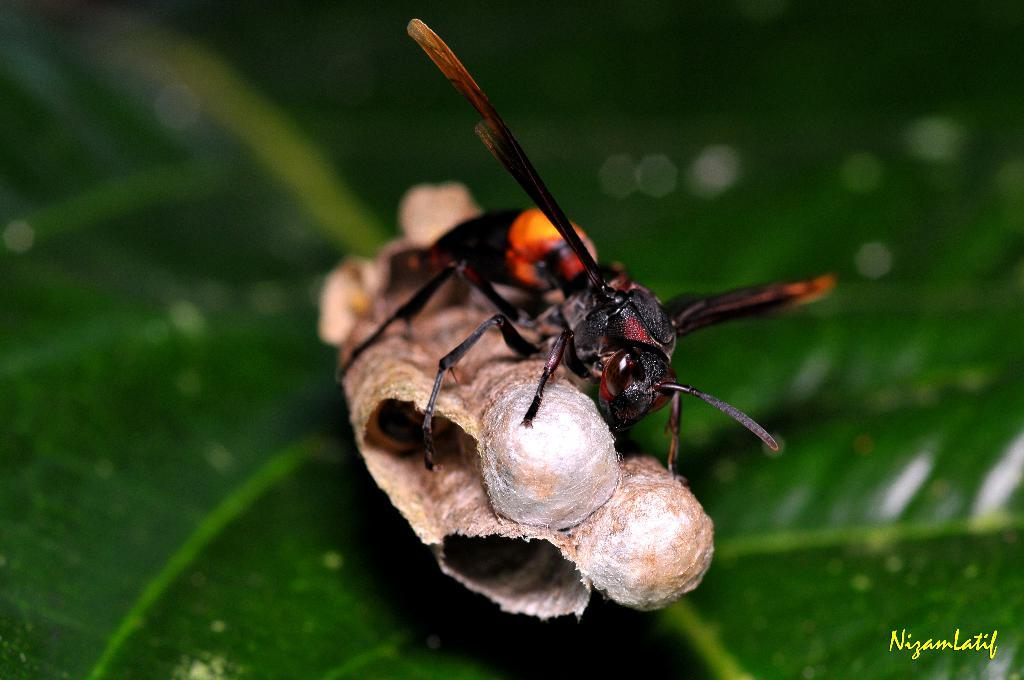What type of creature can be seen in the image? There is an insect in the image. What colors are present on the insect? The insect is black and orange in color. What is the insect sitting on in the image? There is a leaf in the image. Is there any additional mark or feature on the image? Yes, there is a watermark in the image. Can you tell me how many horses are present in the image? There are no horses present in the image; it features an insect on a leaf. What type of property is visible in the image? There is no property visible in the image; it primarily shows an insect and a leaf. 